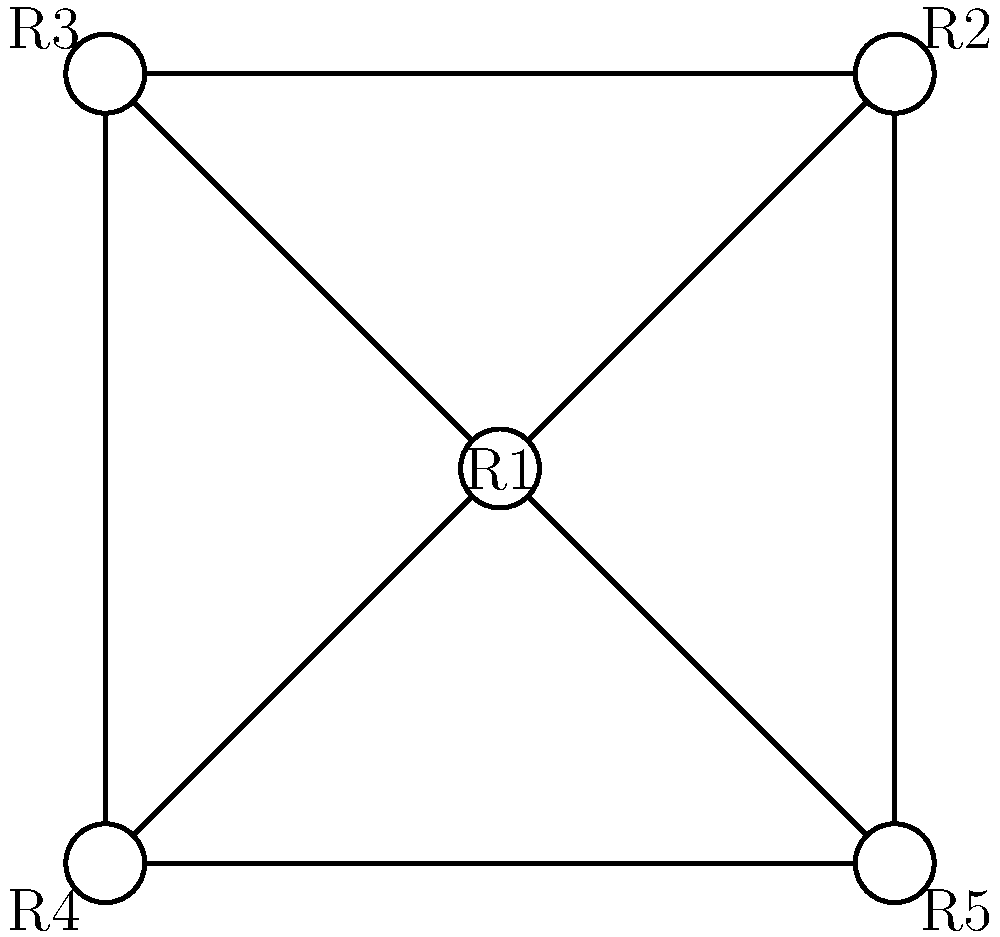In the graph above, each vertex represents a different reality (R1, R2, R3, R4, R5) in the multiverse. The edges represent potential conflicts between realities. To maintain balance and prevent disruptions in the space-time continuum, you need to assign colors to each reality such that no two connected realities have the same color. What is the minimum number of colors required to achieve this, and what does this number represent in terms of managing the multiverse? To solve this problem, we need to apply the concept of graph coloring:

1. Analyze the graph structure:
   - The graph has 5 vertices (realities) and 8 edges (potential conflicts).
   - It forms a wheel graph with R1 at the center connected to all other vertices.

2. Apply the graph coloring algorithm:
   - Start with R1 (center) and assign it color 1.
   - R2, R3, R4, and R5 are all connected to R1, so they must have different colors from R1 and each other.
   - We can assign color 2 to R2, color 3 to R3, color 2 to R4, and color 3 to R5.

3. Verify the coloring:
   - No two adjacent vertices have the same color.
   - We used a total of 3 colors.

4. Check if fewer colors are possible:
   - Due to the wheel structure, we cannot use fewer than 3 colors.
   - If we tried to use only 2 colors, the outer vertices (R2, R3, R4, R5) would create conflicts.

5. Interpret the result:
   - The minimum number of colors (3) represents the minimum number of distinct "states" or "energy levels" needed to keep the realities in balance.
   - Each color group can be thought of as a set of realities that can safely coexist without direct conflicts.

Therefore, the minimum number of colors required is 3, which represents the minimum number of distinct states or energy levels needed to manage and balance the multiverse represented by this graph.
Answer: 3 colors; minimum distinct states to balance the multiverse 